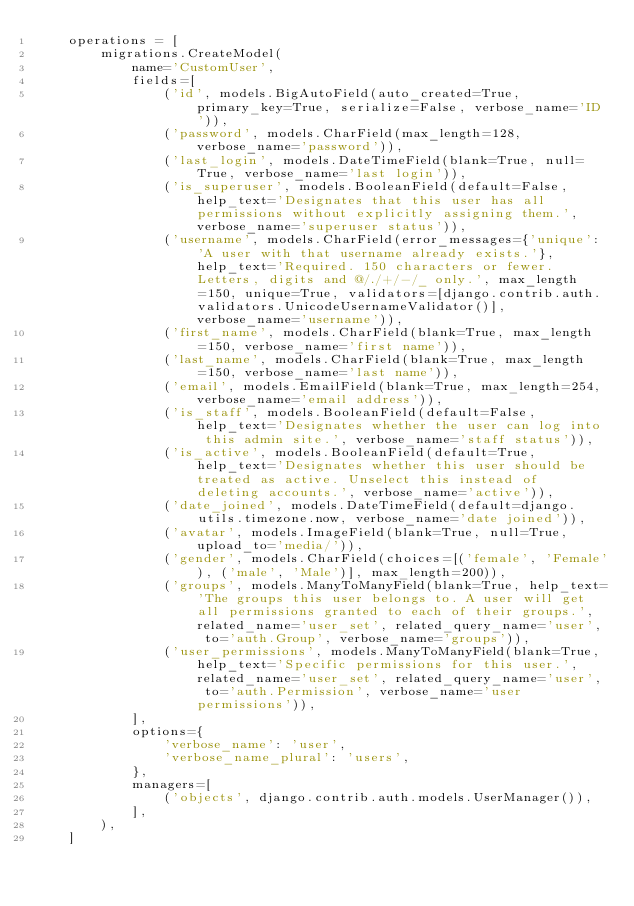Convert code to text. <code><loc_0><loc_0><loc_500><loc_500><_Python_>    operations = [
        migrations.CreateModel(
            name='CustomUser',
            fields=[
                ('id', models.BigAutoField(auto_created=True, primary_key=True, serialize=False, verbose_name='ID')),
                ('password', models.CharField(max_length=128, verbose_name='password')),
                ('last_login', models.DateTimeField(blank=True, null=True, verbose_name='last login')),
                ('is_superuser', models.BooleanField(default=False, help_text='Designates that this user has all permissions without explicitly assigning them.', verbose_name='superuser status')),
                ('username', models.CharField(error_messages={'unique': 'A user with that username already exists.'}, help_text='Required. 150 characters or fewer. Letters, digits and @/./+/-/_ only.', max_length=150, unique=True, validators=[django.contrib.auth.validators.UnicodeUsernameValidator()], verbose_name='username')),
                ('first_name', models.CharField(blank=True, max_length=150, verbose_name='first name')),
                ('last_name', models.CharField(blank=True, max_length=150, verbose_name='last name')),
                ('email', models.EmailField(blank=True, max_length=254, verbose_name='email address')),
                ('is_staff', models.BooleanField(default=False, help_text='Designates whether the user can log into this admin site.', verbose_name='staff status')),
                ('is_active', models.BooleanField(default=True, help_text='Designates whether this user should be treated as active. Unselect this instead of deleting accounts.', verbose_name='active')),
                ('date_joined', models.DateTimeField(default=django.utils.timezone.now, verbose_name='date joined')),
                ('avatar', models.ImageField(blank=True, null=True, upload_to='media/')),
                ('gender', models.CharField(choices=[('female', 'Female'), ('male', 'Male')], max_length=200)),
                ('groups', models.ManyToManyField(blank=True, help_text='The groups this user belongs to. A user will get all permissions granted to each of their groups.', related_name='user_set', related_query_name='user', to='auth.Group', verbose_name='groups')),
                ('user_permissions', models.ManyToManyField(blank=True, help_text='Specific permissions for this user.', related_name='user_set', related_query_name='user', to='auth.Permission', verbose_name='user permissions')),
            ],
            options={
                'verbose_name': 'user',
                'verbose_name_plural': 'users',
            },
            managers=[
                ('objects', django.contrib.auth.models.UserManager()),
            ],
        ),
    ]
</code> 